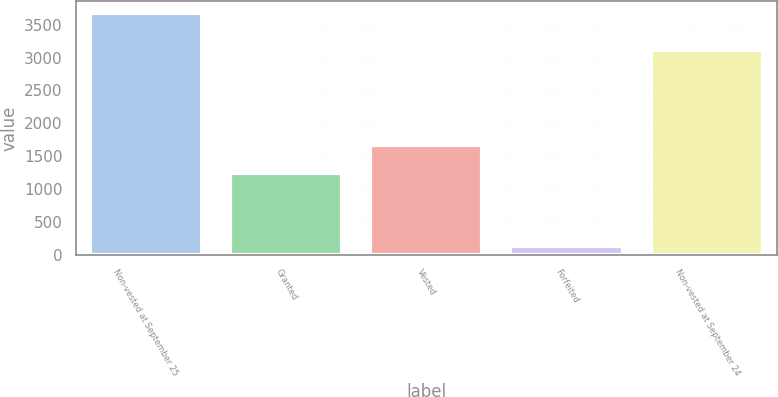Convert chart. <chart><loc_0><loc_0><loc_500><loc_500><bar_chart><fcel>Non-vested at September 25<fcel>Granted<fcel>Vested<fcel>Forfeited<fcel>Non-vested at September 24<nl><fcel>3676<fcel>1236<fcel>1675<fcel>125<fcel>3112<nl></chart> 